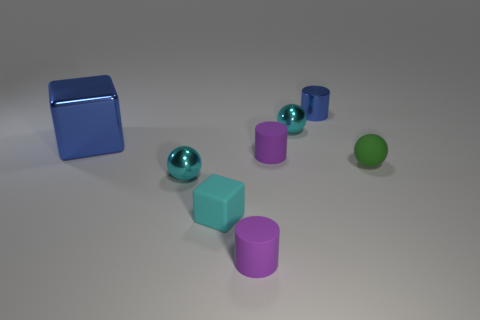Is the blue cylinder made of the same material as the big thing?
Your answer should be compact. Yes. What number of small yellow matte objects are there?
Offer a very short reply. 0. There is a purple cylinder that is in front of the small metallic thing in front of the big shiny object; what size is it?
Provide a short and direct response. Small. What number of other things are there of the same size as the blue cylinder?
Ensure brevity in your answer.  6. There is a cyan rubber cube; how many tiny purple cylinders are in front of it?
Make the answer very short. 1. What size is the cyan matte thing?
Keep it short and to the point. Small. Does the small purple thing behind the small cyan matte thing have the same material as the purple cylinder in front of the green ball?
Provide a succinct answer. Yes. Is there a tiny thing that has the same color as the small rubber cube?
Provide a succinct answer. Yes. What color is the rubber sphere that is the same size as the blue cylinder?
Make the answer very short. Green. Is the color of the rubber sphere on the right side of the small cyan matte object the same as the big object?
Give a very brief answer. No. 